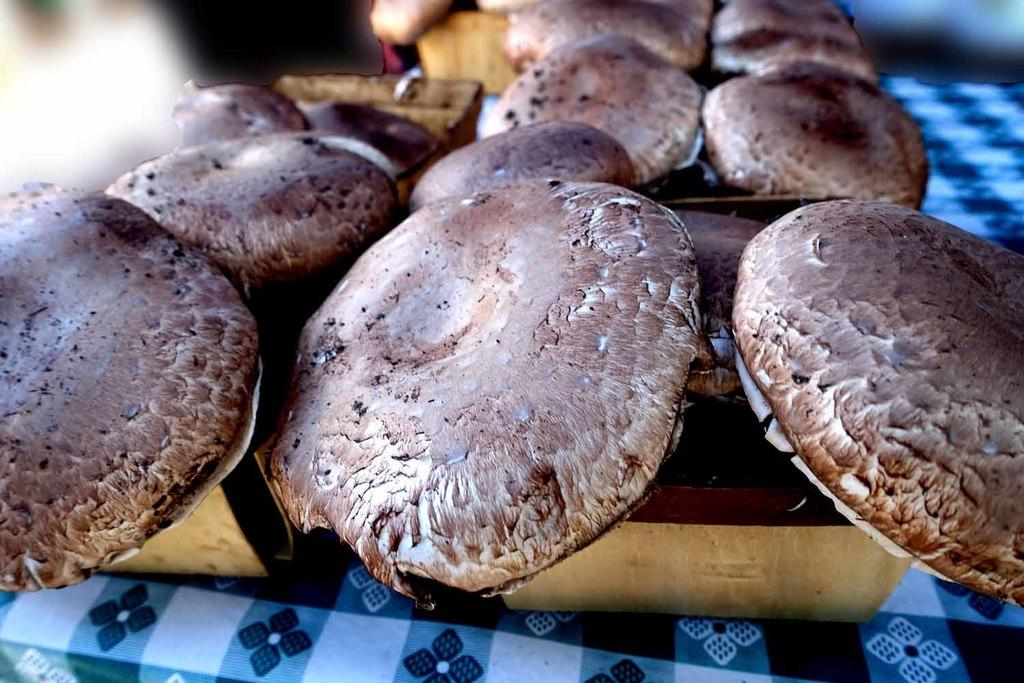What can be seen on the table in the image? There are food items on the table. What type of covering is on the table? There is a cloth on the table. What type of minister is present in the image? There is no minister present in the image; it only features food items and a cloth on the table. How many teeth can be seen in the mouth of the person in the image? A: There is no person or mouth visible in the image, so it is not possible to determine the number of teeth. 